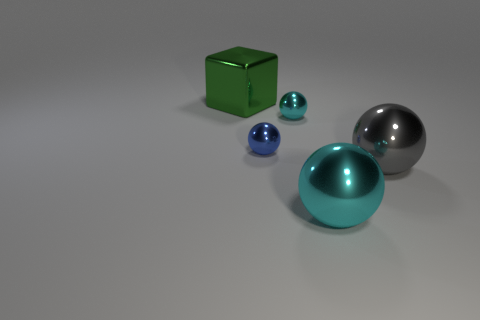Subtract all gray spheres. How many spheres are left? 3 Add 3 cyan rubber things. How many objects exist? 8 Subtract 1 spheres. How many spheres are left? 3 Subtract all green spheres. Subtract all gray cubes. How many spheres are left? 4 Add 5 tiny blue balls. How many tiny blue balls are left? 6 Add 1 tiny green metallic cubes. How many tiny green metallic cubes exist? 1 Subtract 0 blue cylinders. How many objects are left? 5 Subtract all cubes. How many objects are left? 4 Subtract all blue rubber spheres. Subtract all large metallic things. How many objects are left? 2 